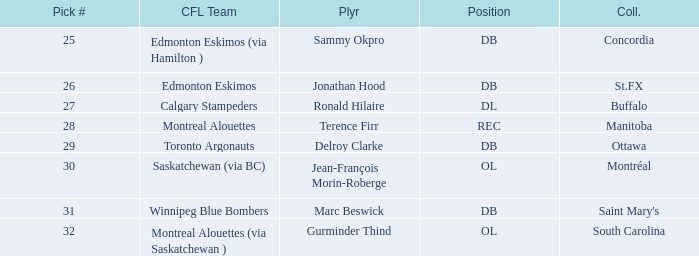Which College has a Pick # larger than 30, and a Position of ol? South Carolina. 